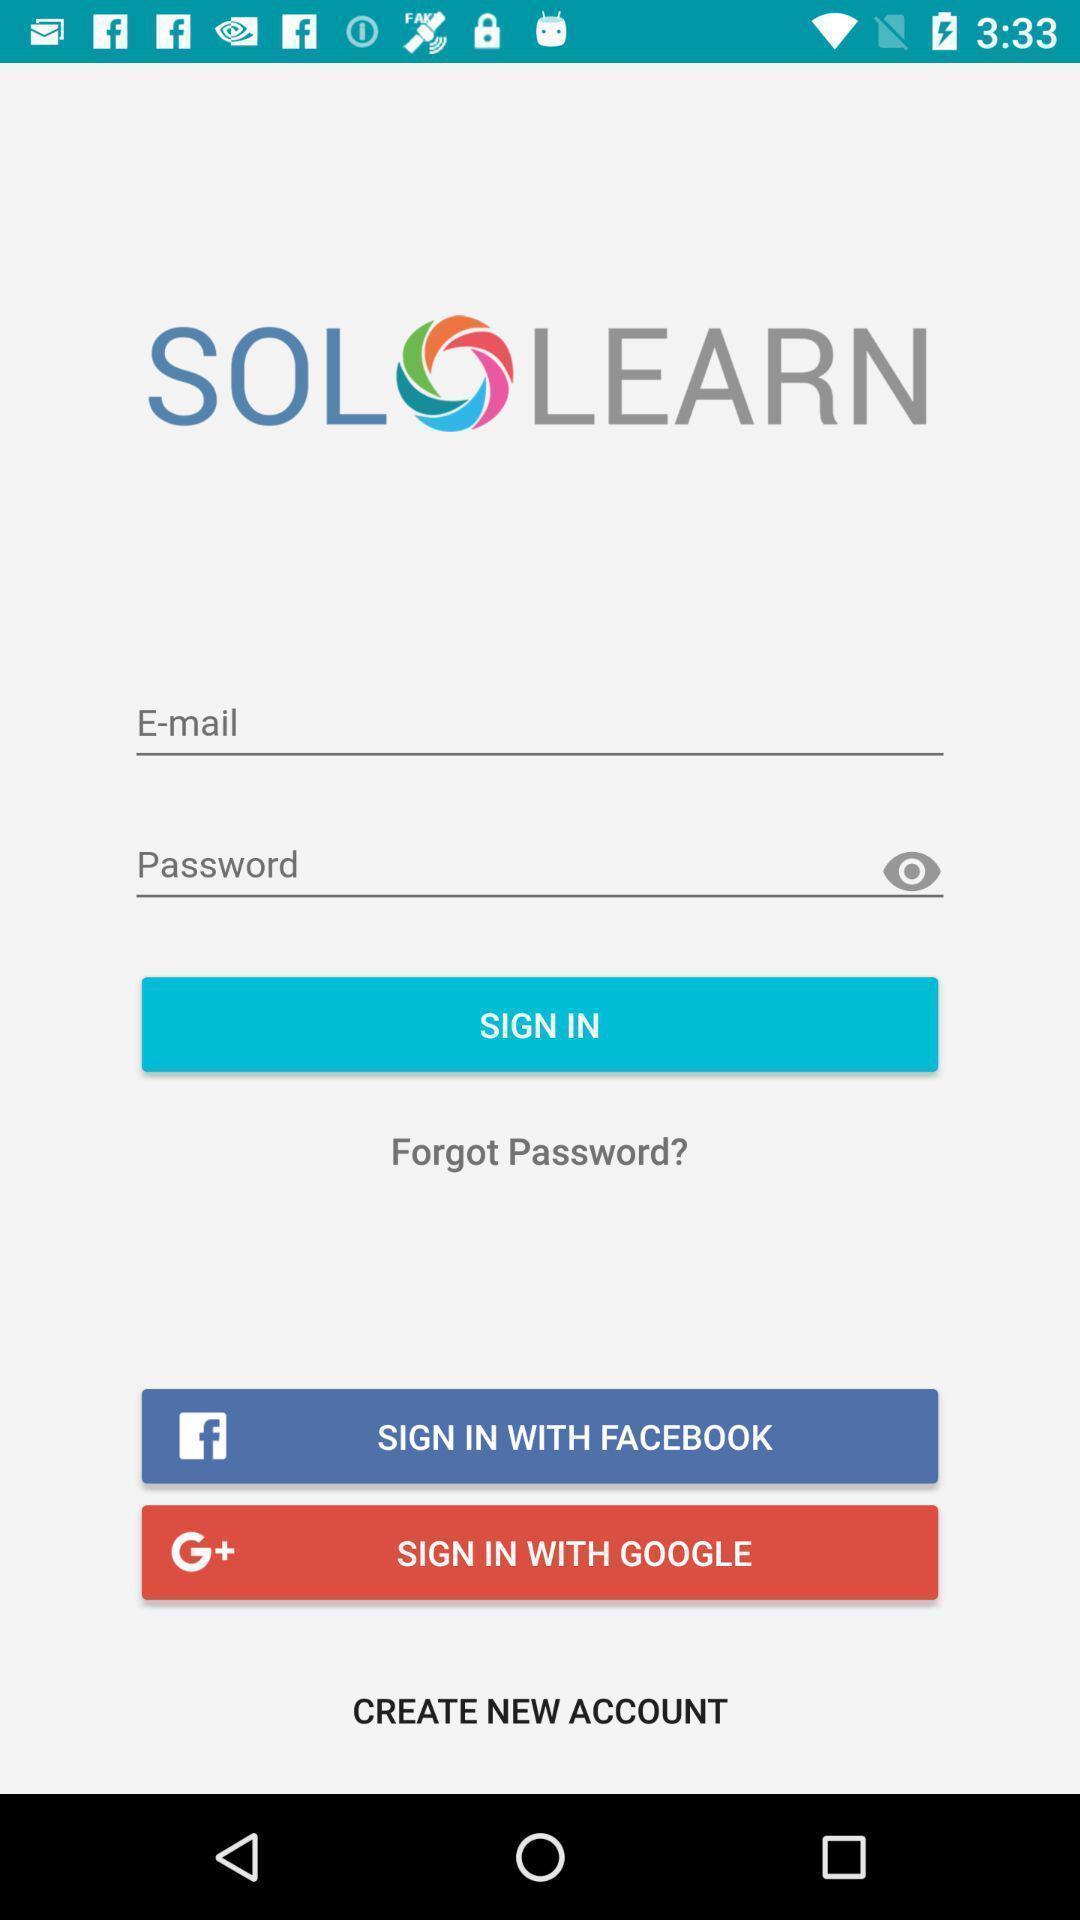Summarize the information in this screenshot. Sign page. 